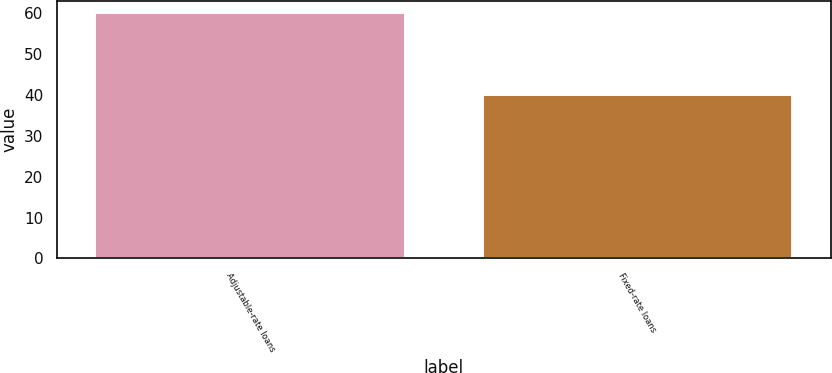Convert chart. <chart><loc_0><loc_0><loc_500><loc_500><bar_chart><fcel>Adjustable-rate loans<fcel>Fixed-rate loans<nl><fcel>60<fcel>40<nl></chart> 